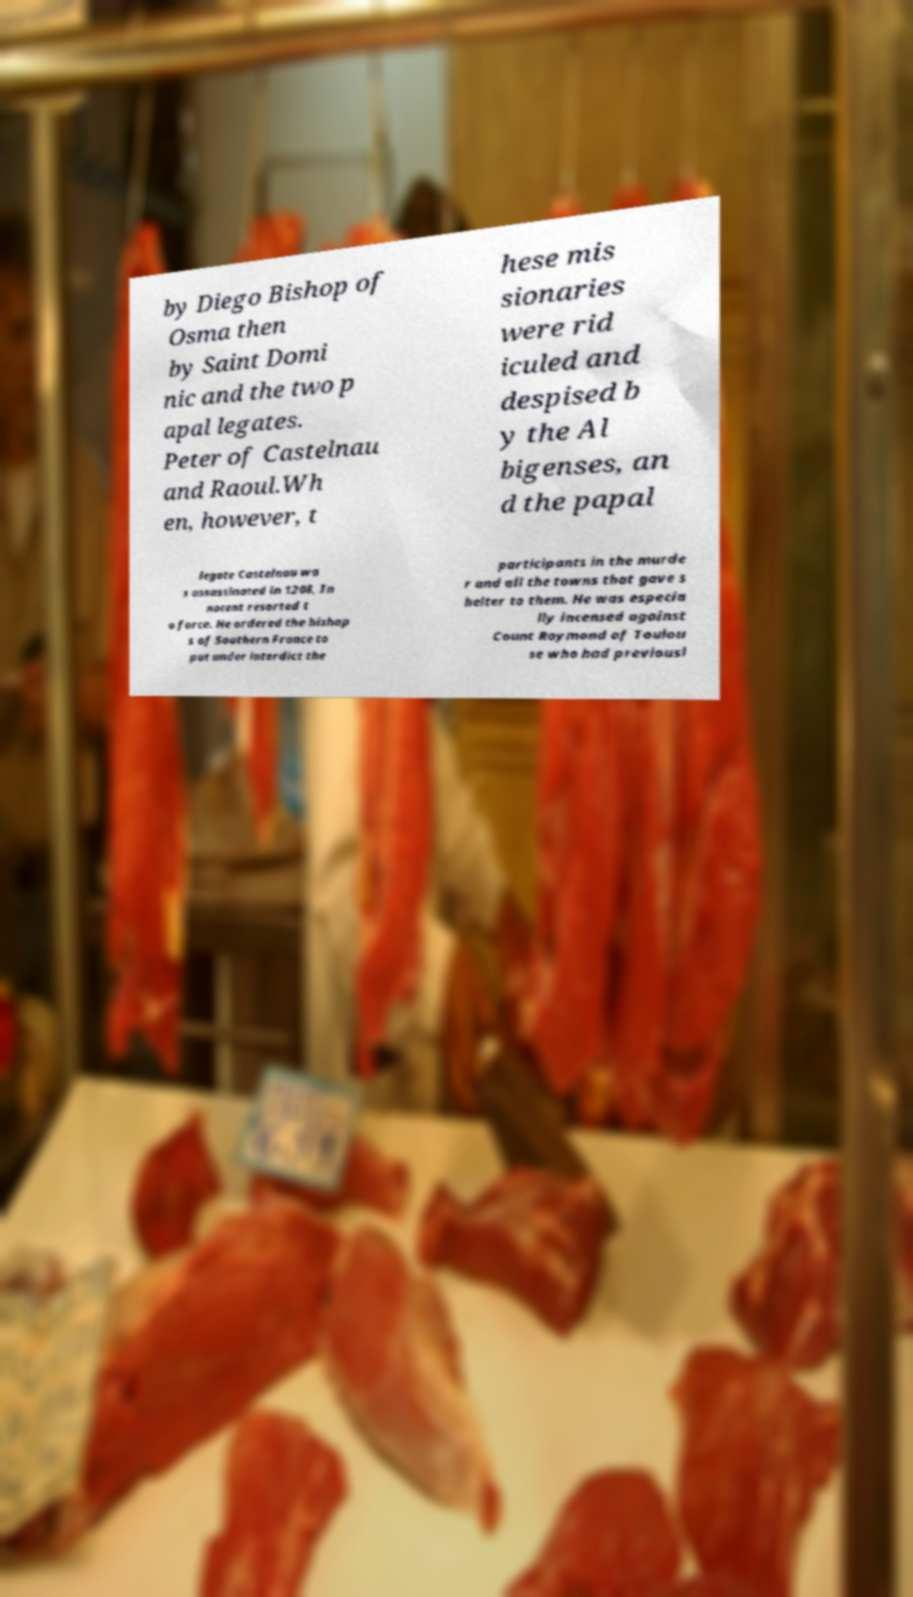I need the written content from this picture converted into text. Can you do that? by Diego Bishop of Osma then by Saint Domi nic and the two p apal legates. Peter of Castelnau and Raoul.Wh en, however, t hese mis sionaries were rid iculed and despised b y the Al bigenses, an d the papal legate Castelnau wa s assassinated in 1208, In nocent resorted t o force. He ordered the bishop s of Southern France to put under interdict the participants in the murde r and all the towns that gave s helter to them. He was especia lly incensed against Count Raymond of Toulou se who had previousl 